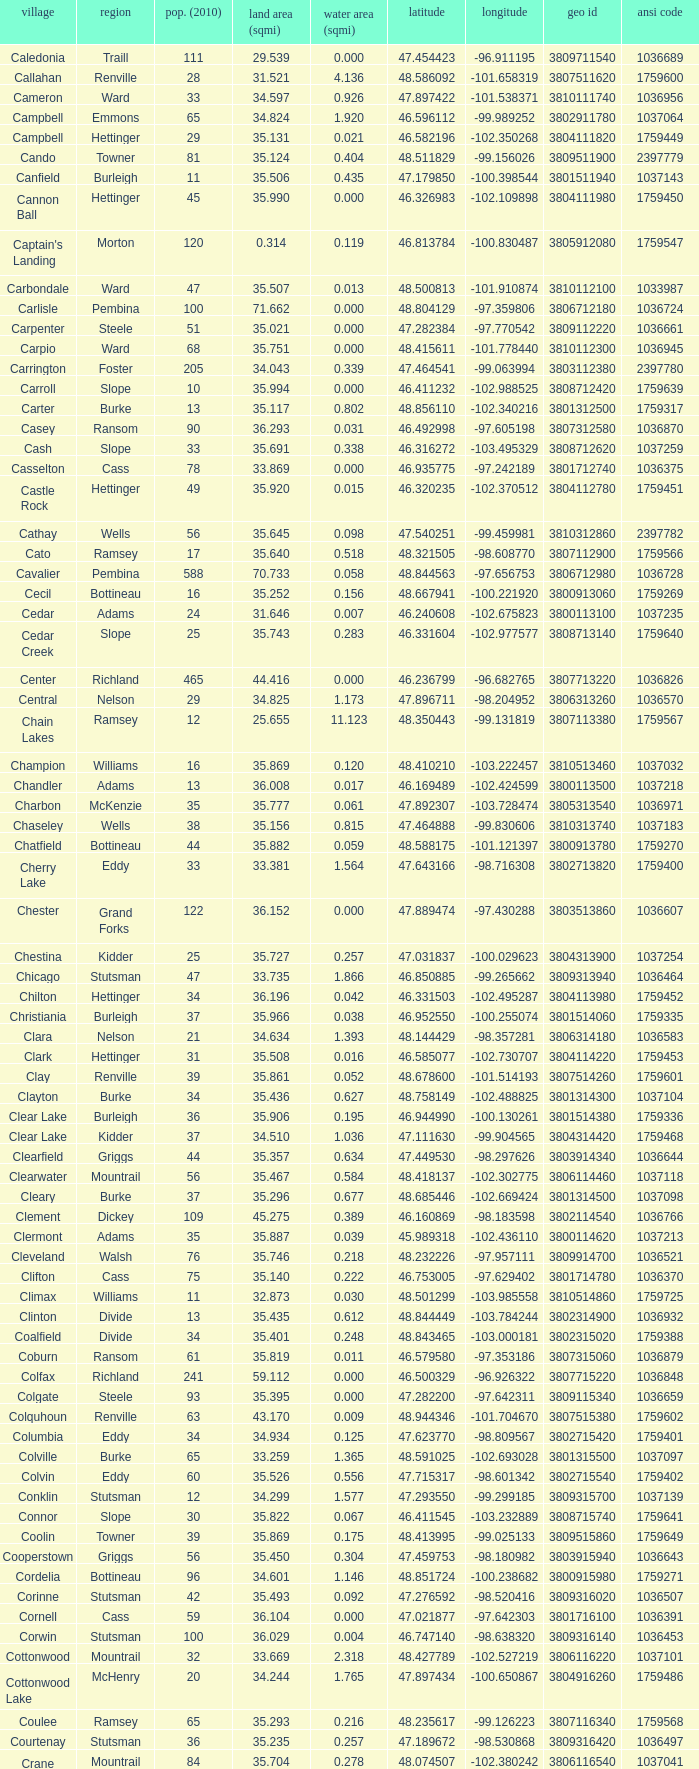What was the latitude of the Clearwater townsship? 48.418137. 